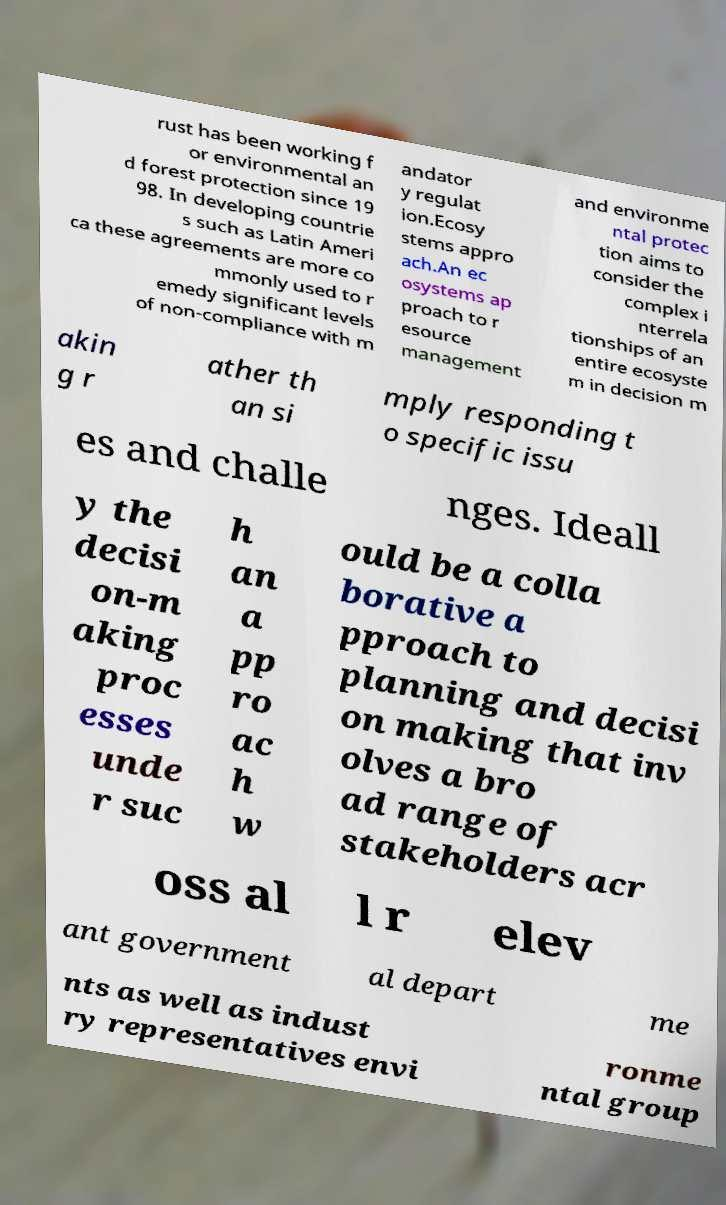I need the written content from this picture converted into text. Can you do that? rust has been working f or environmental an d forest protection since 19 98. In developing countrie s such as Latin Ameri ca these agreements are more co mmonly used to r emedy significant levels of non-compliance with m andator y regulat ion.Ecosy stems appro ach.An ec osystems ap proach to r esource management and environme ntal protec tion aims to consider the complex i nterrela tionships of an entire ecosyste m in decision m akin g r ather th an si mply responding t o specific issu es and challe nges. Ideall y the decisi on-m aking proc esses unde r suc h an a pp ro ac h w ould be a colla borative a pproach to planning and decisi on making that inv olves a bro ad range of stakeholders acr oss al l r elev ant government al depart me nts as well as indust ry representatives envi ronme ntal group 